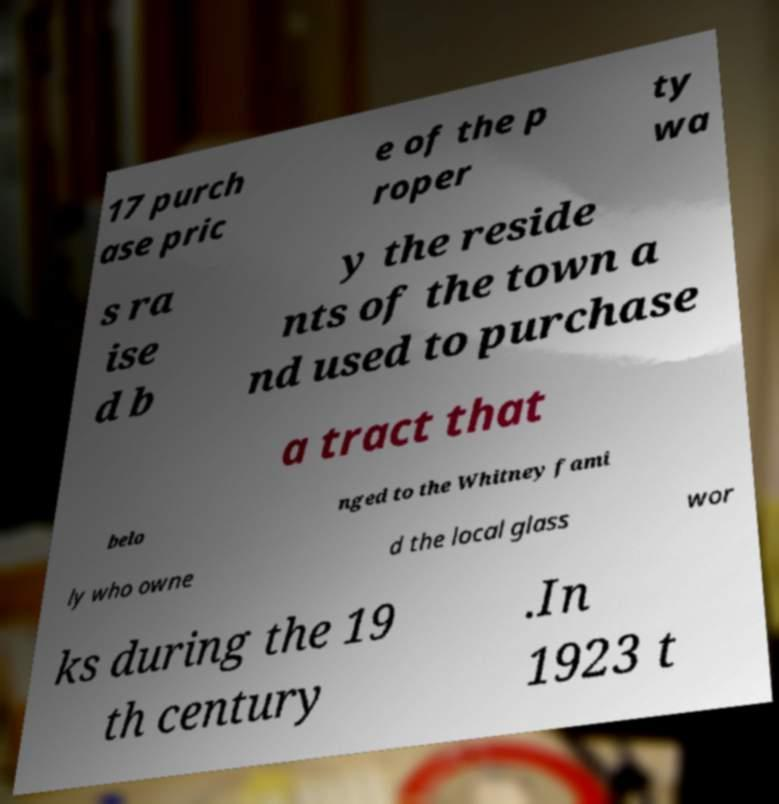For documentation purposes, I need the text within this image transcribed. Could you provide that? 17 purch ase pric e of the p roper ty wa s ra ise d b y the reside nts of the town a nd used to purchase a tract that belo nged to the Whitney fami ly who owne d the local glass wor ks during the 19 th century .In 1923 t 